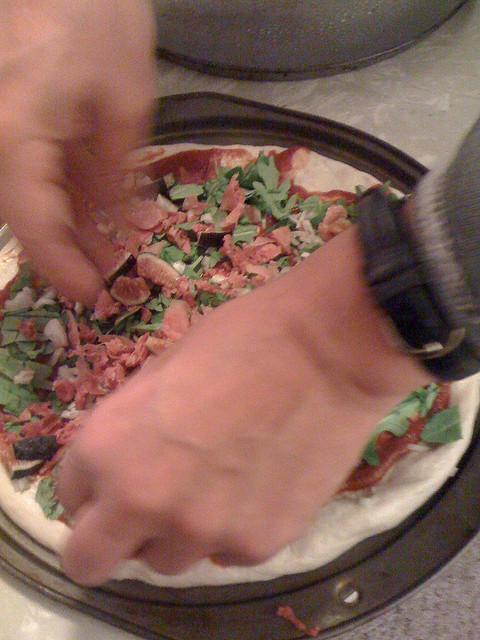How many people are in the picture?
Give a very brief answer. 2. How many red buses are there?
Give a very brief answer. 0. 